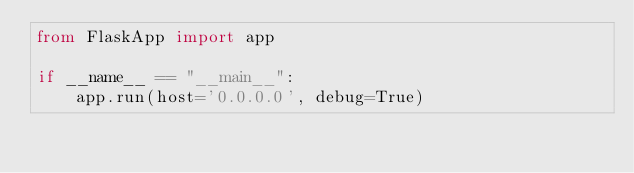<code> <loc_0><loc_0><loc_500><loc_500><_Python_>from FlaskApp import app

if __name__ == "__main__":
    app.run(host='0.0.0.0', debug=True)
</code> 